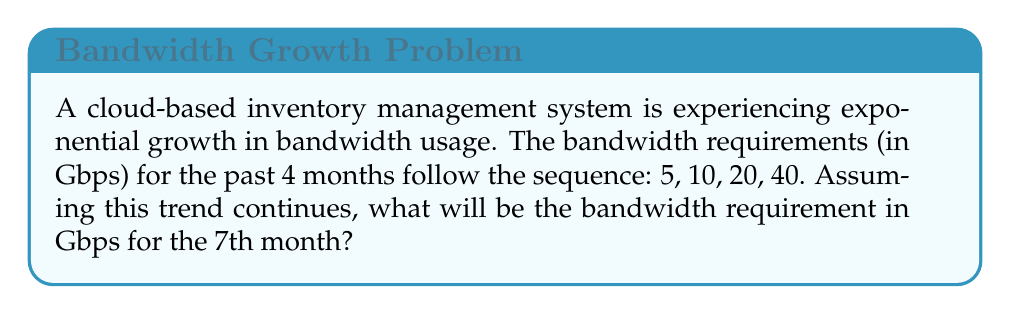Help me with this question. To solve this problem, we need to:

1. Identify the pattern in the given sequence:
   $5, 10, 20, 40$

2. Recognize that this is a geometric sequence with a common ratio:
   $\frac{10}{5} = \frac{20}{10} = \frac{40}{20} = 2$

3. Express the general term of the sequence:
   $a_n = a_1 \cdot r^{n-1}$
   Where $a_1 = 5$ (first term) and $r = 2$ (common ratio)

4. Calculate the 7th term:
   $a_7 = 5 \cdot 2^{7-1}$
   $a_7 = 5 \cdot 2^6$
   $a_7 = 5 \cdot 64$
   $a_7 = 320$

Therefore, the bandwidth requirement for the 7th month will be 320 Gbps.
Answer: 320 Gbps 